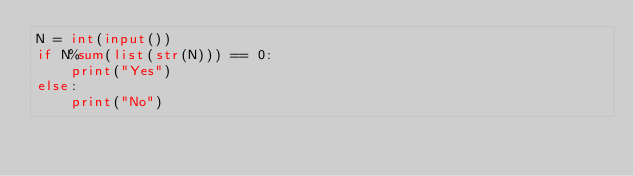Convert code to text. <code><loc_0><loc_0><loc_500><loc_500><_Python_>N = int(input())
if N%sum(list(str(N))) == 0:
    print("Yes")
else:
    print("No")</code> 